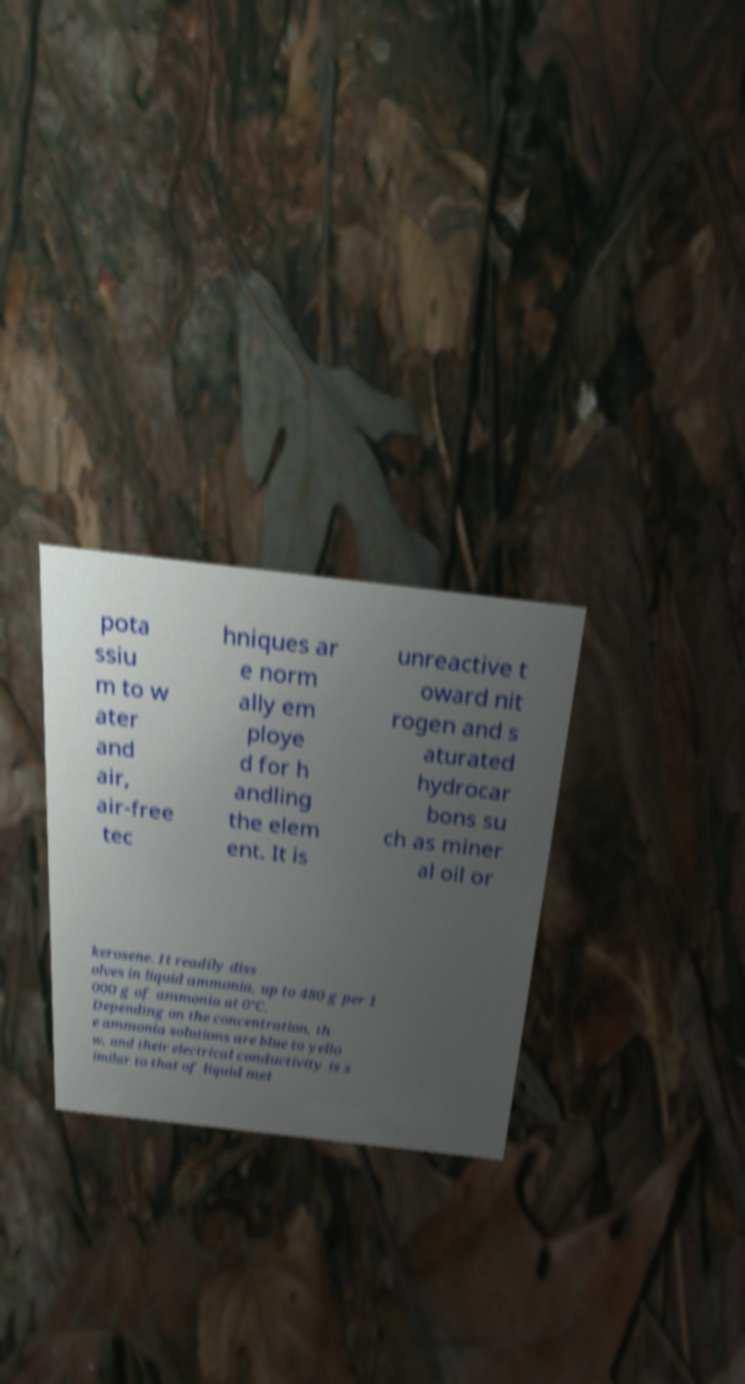For documentation purposes, I need the text within this image transcribed. Could you provide that? pota ssiu m to w ater and air, air-free tec hniques ar e norm ally em ploye d for h andling the elem ent. It is unreactive t oward nit rogen and s aturated hydrocar bons su ch as miner al oil or kerosene. It readily diss olves in liquid ammonia, up to 480 g per 1 000 g of ammonia at 0°C. Depending on the concentration, th e ammonia solutions are blue to yello w, and their electrical conductivity is s imilar to that of liquid met 